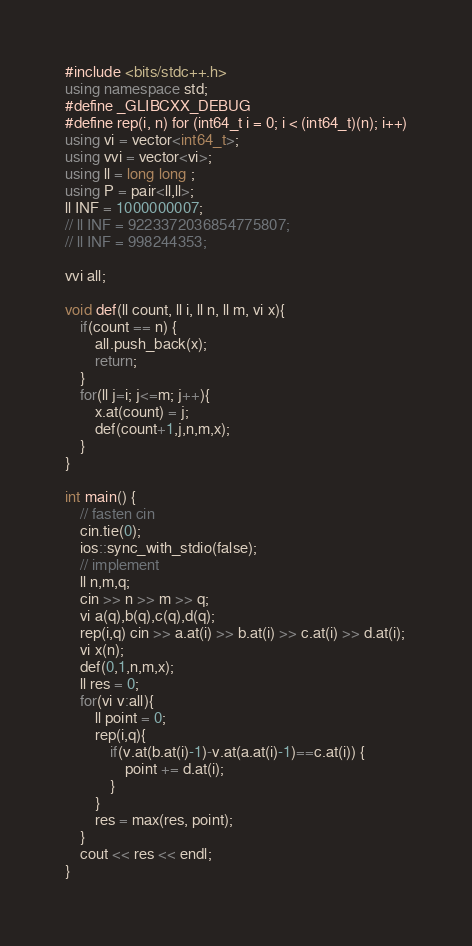<code> <loc_0><loc_0><loc_500><loc_500><_C++_>#include <bits/stdc++.h>
using namespace std;
#define _GLIBCXX_DEBUG
#define rep(i, n) for (int64_t i = 0; i < (int64_t)(n); i++)
using vi = vector<int64_t>;
using vvi = vector<vi>;
using ll = long long ;
using P = pair<ll,ll>;
ll INF = 1000000007;
// ll INF = 9223372036854775807;
// ll INF = 998244353;

vvi all;

void def(ll count, ll i, ll n, ll m, vi x){
    if(count == n) {
        all.push_back(x);
        return;
    }
    for(ll j=i; j<=m; j++){
        x.at(count) = j;
        def(count+1,j,n,m,x);
    }
}

int main() {
    // fasten cin
    cin.tie(0);
    ios::sync_with_stdio(false);
    // implement
    ll n,m,q;
    cin >> n >> m >> q;
    vi a(q),b(q),c(q),d(q);
    rep(i,q) cin >> a.at(i) >> b.at(i) >> c.at(i) >> d.at(i);
    vi x(n);
    def(0,1,n,m,x);
    ll res = 0;
    for(vi v:all){
        ll point = 0;
        rep(i,q){
            if(v.at(b.at(i)-1)-v.at(a.at(i)-1)==c.at(i)) {
                point += d.at(i);
            }
        }
        res = max(res, point);
    }
    cout << res << endl;
}</code> 